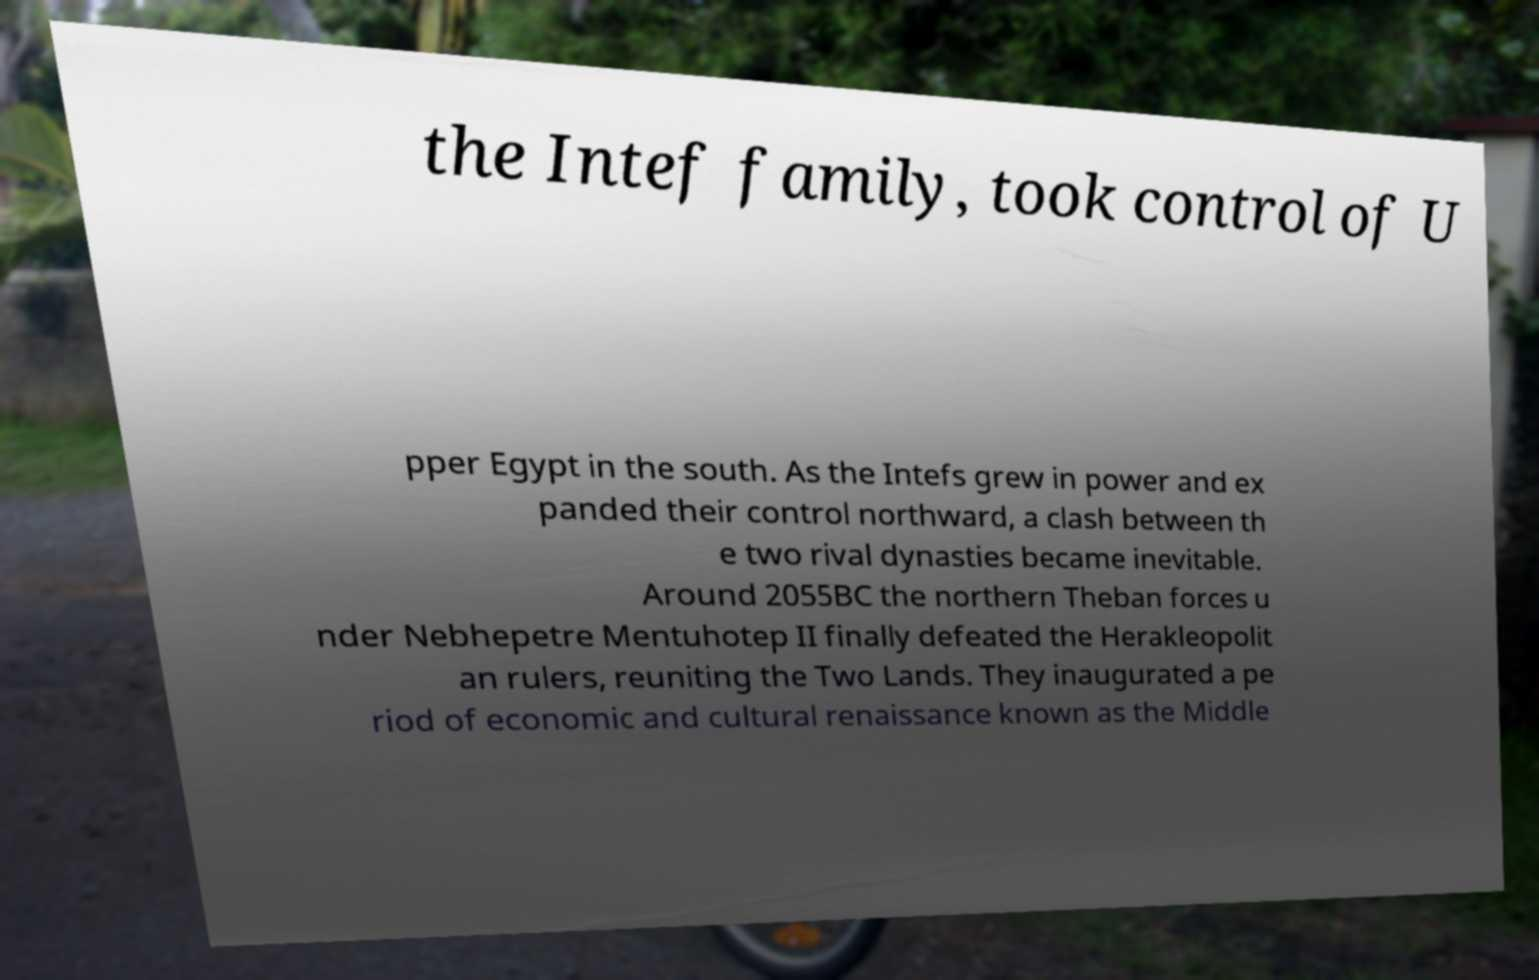I need the written content from this picture converted into text. Can you do that? the Intef family, took control of U pper Egypt in the south. As the Intefs grew in power and ex panded their control northward, a clash between th e two rival dynasties became inevitable. Around 2055BC the northern Theban forces u nder Nebhepetre Mentuhotep II finally defeated the Herakleopolit an rulers, reuniting the Two Lands. They inaugurated a pe riod of economic and cultural renaissance known as the Middle 